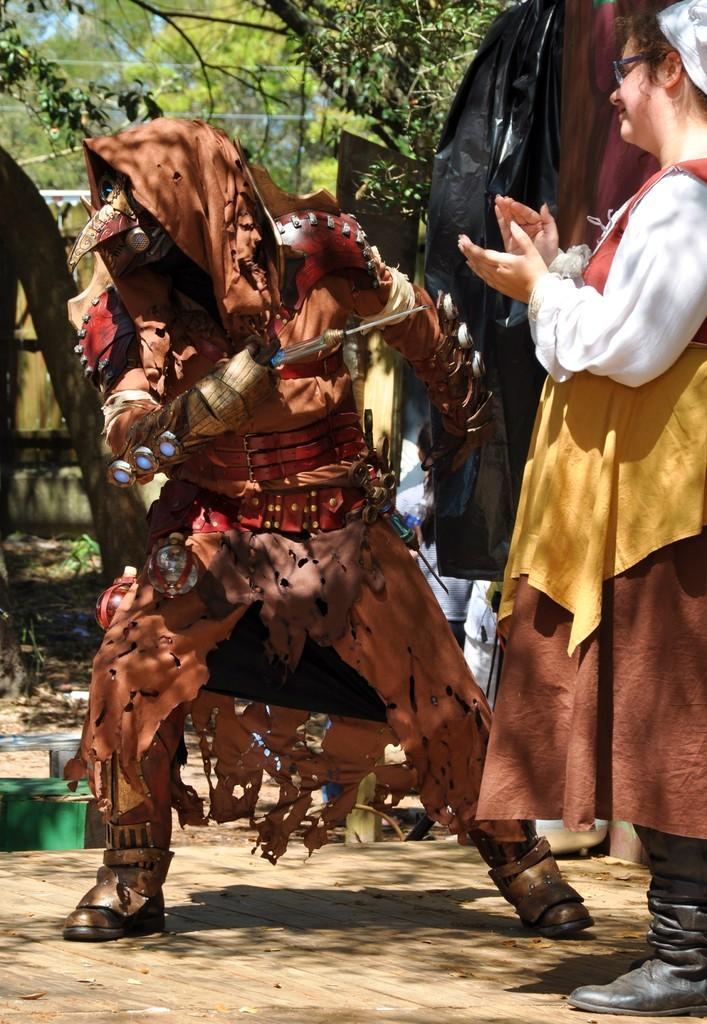What is the person in the center of the image holding? The person is holding a knife in the image. What is the lady on the right side of the image doing? The lady is clapping her hands in the image. What can be seen in the background of the image? There are trees in the background of the image. How many bridges can be seen in the image? There are no bridges present in the image. What type of stitch is the person using to hold the knife? The person is not using a stitch to hold the knife; they are simply gripping it. 